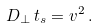<formula> <loc_0><loc_0><loc_500><loc_500>D _ { \bot } \, t _ { s } = v ^ { 2 } \, .</formula> 